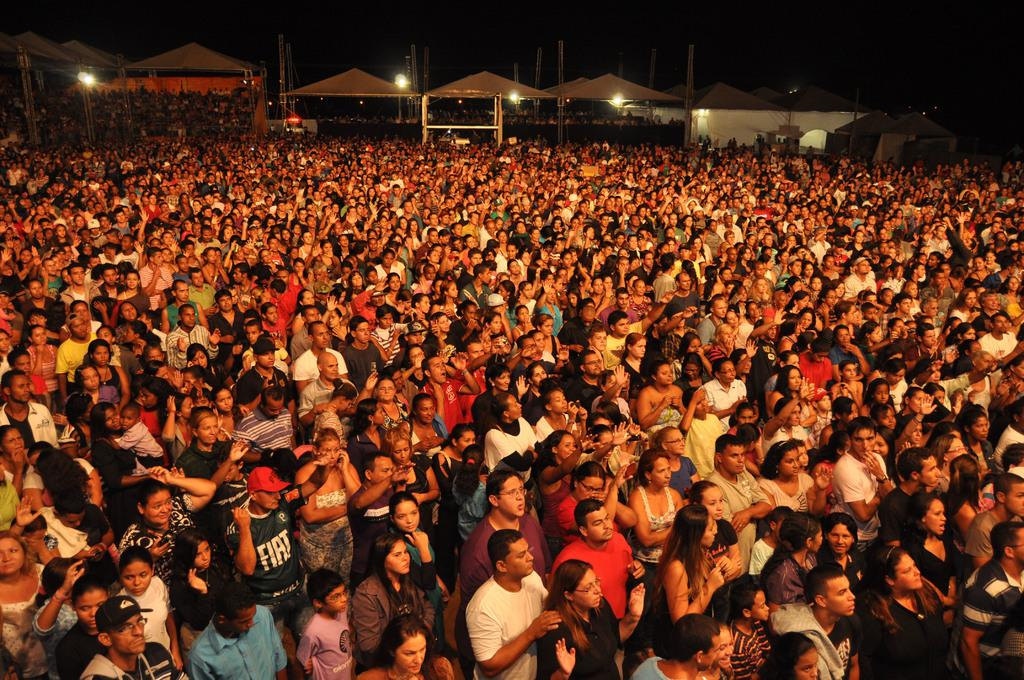What can be seen in the image? There are people standing in the image. What is the surface that the people are standing on? The people are standing on a surface, likely a floor. What can be seen in the distance behind the people? There are buildings and lights visible in the background of the image. What type of oven is being used by the people in the image? There is no oven present in the image; it features people standing on a surface with buildings and lights visible in the background. 